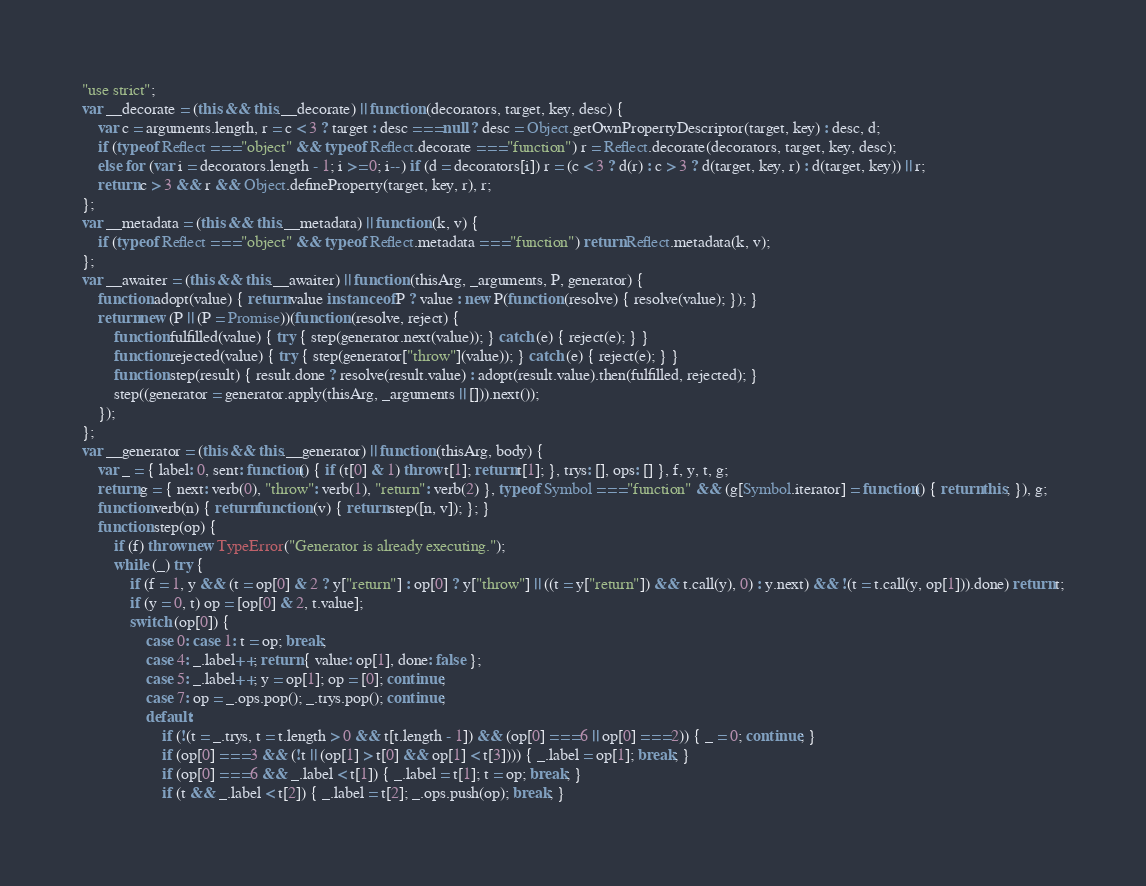Convert code to text. <code><loc_0><loc_0><loc_500><loc_500><_JavaScript_>"use strict";
var __decorate = (this && this.__decorate) || function (decorators, target, key, desc) {
    var c = arguments.length, r = c < 3 ? target : desc === null ? desc = Object.getOwnPropertyDescriptor(target, key) : desc, d;
    if (typeof Reflect === "object" && typeof Reflect.decorate === "function") r = Reflect.decorate(decorators, target, key, desc);
    else for (var i = decorators.length - 1; i >= 0; i--) if (d = decorators[i]) r = (c < 3 ? d(r) : c > 3 ? d(target, key, r) : d(target, key)) || r;
    return c > 3 && r && Object.defineProperty(target, key, r), r;
};
var __metadata = (this && this.__metadata) || function (k, v) {
    if (typeof Reflect === "object" && typeof Reflect.metadata === "function") return Reflect.metadata(k, v);
};
var __awaiter = (this && this.__awaiter) || function (thisArg, _arguments, P, generator) {
    function adopt(value) { return value instanceof P ? value : new P(function (resolve) { resolve(value); }); }
    return new (P || (P = Promise))(function (resolve, reject) {
        function fulfilled(value) { try { step(generator.next(value)); } catch (e) { reject(e); } }
        function rejected(value) { try { step(generator["throw"](value)); } catch (e) { reject(e); } }
        function step(result) { result.done ? resolve(result.value) : adopt(result.value).then(fulfilled, rejected); }
        step((generator = generator.apply(thisArg, _arguments || [])).next());
    });
};
var __generator = (this && this.__generator) || function (thisArg, body) {
    var _ = { label: 0, sent: function() { if (t[0] & 1) throw t[1]; return t[1]; }, trys: [], ops: [] }, f, y, t, g;
    return g = { next: verb(0), "throw": verb(1), "return": verb(2) }, typeof Symbol === "function" && (g[Symbol.iterator] = function() { return this; }), g;
    function verb(n) { return function (v) { return step([n, v]); }; }
    function step(op) {
        if (f) throw new TypeError("Generator is already executing.");
        while (_) try {
            if (f = 1, y && (t = op[0] & 2 ? y["return"] : op[0] ? y["throw"] || ((t = y["return"]) && t.call(y), 0) : y.next) && !(t = t.call(y, op[1])).done) return t;
            if (y = 0, t) op = [op[0] & 2, t.value];
            switch (op[0]) {
                case 0: case 1: t = op; break;
                case 4: _.label++; return { value: op[1], done: false };
                case 5: _.label++; y = op[1]; op = [0]; continue;
                case 7: op = _.ops.pop(); _.trys.pop(); continue;
                default:
                    if (!(t = _.trys, t = t.length > 0 && t[t.length - 1]) && (op[0] === 6 || op[0] === 2)) { _ = 0; continue; }
                    if (op[0] === 3 && (!t || (op[1] > t[0] && op[1] < t[3]))) { _.label = op[1]; break; }
                    if (op[0] === 6 && _.label < t[1]) { _.label = t[1]; t = op; break; }
                    if (t && _.label < t[2]) { _.label = t[2]; _.ops.push(op); break; }</code> 